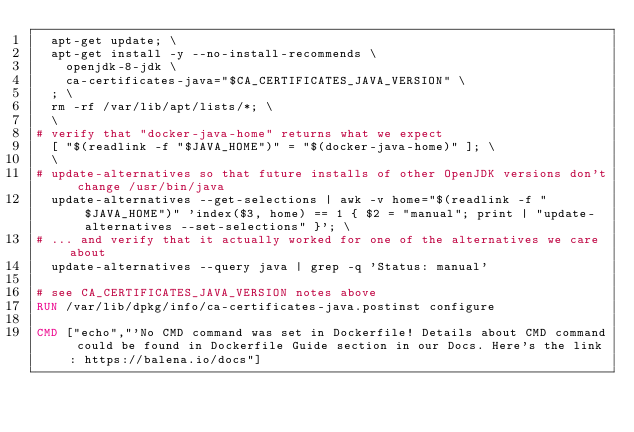<code> <loc_0><loc_0><loc_500><loc_500><_Dockerfile_>	apt-get update; \
	apt-get install -y --no-install-recommends \
		openjdk-8-jdk \
		ca-certificates-java="$CA_CERTIFICATES_JAVA_VERSION" \
	; \
	rm -rf /var/lib/apt/lists/*; \
	\
# verify that "docker-java-home" returns what we expect
	[ "$(readlink -f "$JAVA_HOME")" = "$(docker-java-home)" ]; \
	\
# update-alternatives so that future installs of other OpenJDK versions don't change /usr/bin/java
	update-alternatives --get-selections | awk -v home="$(readlink -f "$JAVA_HOME")" 'index($3, home) == 1 { $2 = "manual"; print | "update-alternatives --set-selections" }'; \
# ... and verify that it actually worked for one of the alternatives we care about
	update-alternatives --query java | grep -q 'Status: manual'

# see CA_CERTIFICATES_JAVA_VERSION notes above
RUN /var/lib/dpkg/info/ca-certificates-java.postinst configure

CMD ["echo","'No CMD command was set in Dockerfile! Details about CMD command could be found in Dockerfile Guide section in our Docs. Here's the link: https://balena.io/docs"]</code> 